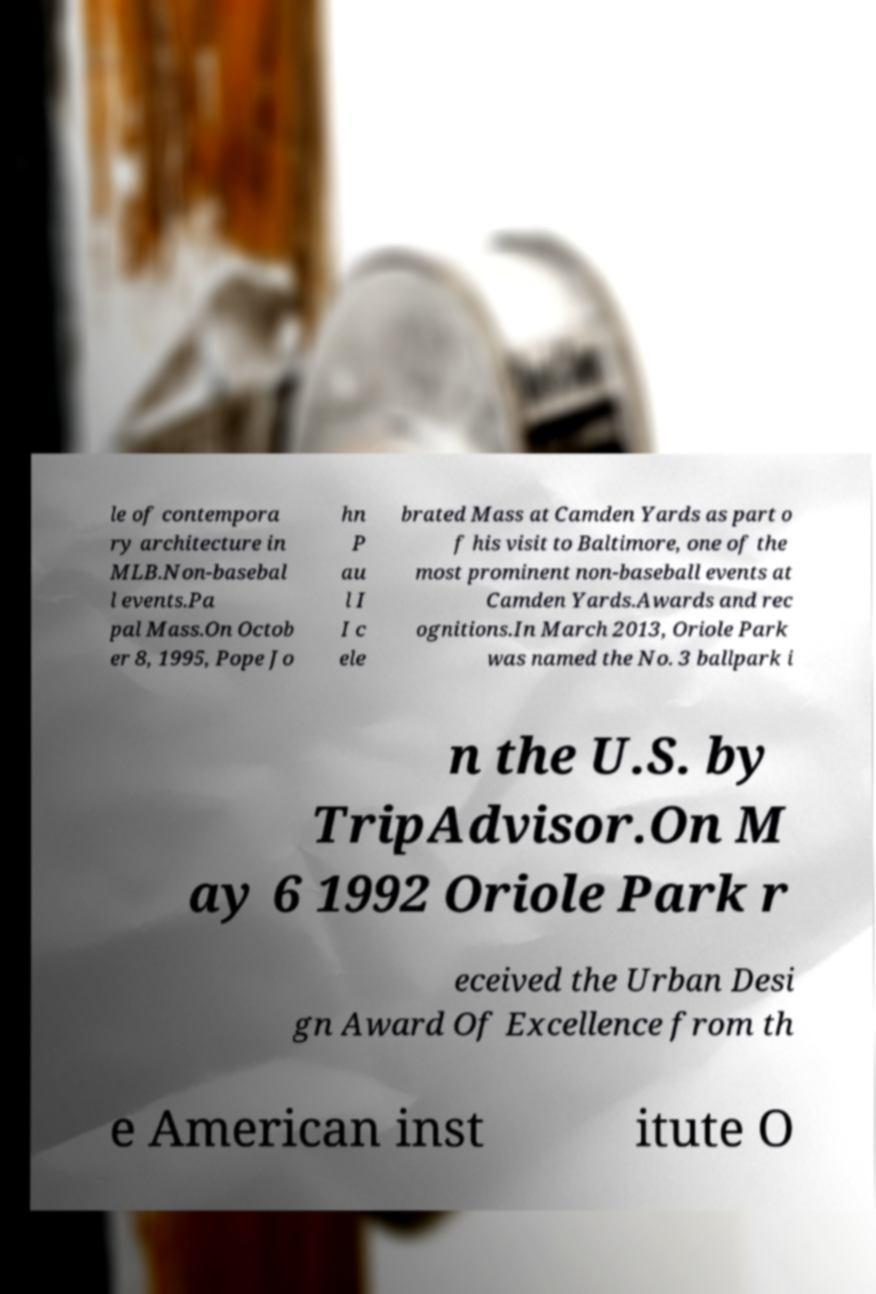I need the written content from this picture converted into text. Can you do that? le of contempora ry architecture in MLB.Non-basebal l events.Pa pal Mass.On Octob er 8, 1995, Pope Jo hn P au l I I c ele brated Mass at Camden Yards as part o f his visit to Baltimore, one of the most prominent non-baseball events at Camden Yards.Awards and rec ognitions.In March 2013, Oriole Park was named the No. 3 ballpark i n the U.S. by TripAdvisor.On M ay 6 1992 Oriole Park r eceived the Urban Desi gn Award Of Excellence from th e American inst itute O 